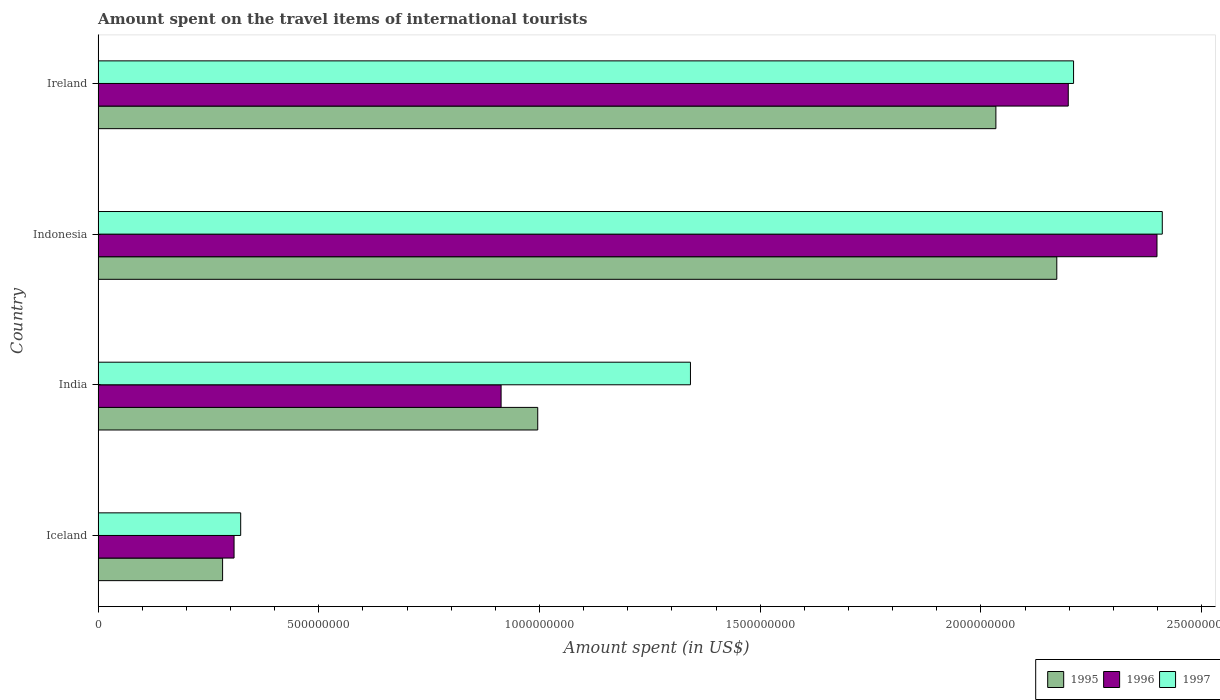How many groups of bars are there?
Offer a terse response. 4. Are the number of bars per tick equal to the number of legend labels?
Make the answer very short. Yes. Are the number of bars on each tick of the Y-axis equal?
Keep it short and to the point. Yes. What is the label of the 3rd group of bars from the top?
Your response must be concise. India. What is the amount spent on the travel items of international tourists in 1997 in Iceland?
Provide a succinct answer. 3.23e+08. Across all countries, what is the maximum amount spent on the travel items of international tourists in 1997?
Keep it short and to the point. 2.41e+09. Across all countries, what is the minimum amount spent on the travel items of international tourists in 1996?
Ensure brevity in your answer.  3.08e+08. In which country was the amount spent on the travel items of international tourists in 1996 maximum?
Make the answer very short. Indonesia. In which country was the amount spent on the travel items of international tourists in 1997 minimum?
Make the answer very short. Iceland. What is the total amount spent on the travel items of international tourists in 1995 in the graph?
Give a very brief answer. 5.48e+09. What is the difference between the amount spent on the travel items of international tourists in 1995 in Iceland and that in Indonesia?
Keep it short and to the point. -1.89e+09. What is the difference between the amount spent on the travel items of international tourists in 1997 in India and the amount spent on the travel items of international tourists in 1995 in Indonesia?
Keep it short and to the point. -8.30e+08. What is the average amount spent on the travel items of international tourists in 1996 per country?
Make the answer very short. 1.45e+09. What is the difference between the amount spent on the travel items of international tourists in 1995 and amount spent on the travel items of international tourists in 1997 in India?
Your response must be concise. -3.46e+08. In how many countries, is the amount spent on the travel items of international tourists in 1995 greater than 400000000 US$?
Your answer should be compact. 3. What is the ratio of the amount spent on the travel items of international tourists in 1996 in India to that in Indonesia?
Provide a short and direct response. 0.38. Is the amount spent on the travel items of international tourists in 1996 in Indonesia less than that in Ireland?
Offer a terse response. No. What is the difference between the highest and the second highest amount spent on the travel items of international tourists in 1995?
Give a very brief answer. 1.38e+08. What is the difference between the highest and the lowest amount spent on the travel items of international tourists in 1997?
Your answer should be compact. 2.09e+09. In how many countries, is the amount spent on the travel items of international tourists in 1996 greater than the average amount spent on the travel items of international tourists in 1996 taken over all countries?
Ensure brevity in your answer.  2. Is the sum of the amount spent on the travel items of international tourists in 1997 in Indonesia and Ireland greater than the maximum amount spent on the travel items of international tourists in 1995 across all countries?
Your response must be concise. Yes. Is it the case that in every country, the sum of the amount spent on the travel items of international tourists in 1995 and amount spent on the travel items of international tourists in 1997 is greater than the amount spent on the travel items of international tourists in 1996?
Keep it short and to the point. Yes. Does the graph contain any zero values?
Keep it short and to the point. No. How many legend labels are there?
Give a very brief answer. 3. What is the title of the graph?
Your answer should be very brief. Amount spent on the travel items of international tourists. Does "1993" appear as one of the legend labels in the graph?
Your answer should be compact. No. What is the label or title of the X-axis?
Your response must be concise. Amount spent (in US$). What is the Amount spent (in US$) of 1995 in Iceland?
Your answer should be very brief. 2.82e+08. What is the Amount spent (in US$) of 1996 in Iceland?
Provide a succinct answer. 3.08e+08. What is the Amount spent (in US$) in 1997 in Iceland?
Make the answer very short. 3.23e+08. What is the Amount spent (in US$) of 1995 in India?
Keep it short and to the point. 9.96e+08. What is the Amount spent (in US$) in 1996 in India?
Your answer should be compact. 9.13e+08. What is the Amount spent (in US$) in 1997 in India?
Offer a terse response. 1.34e+09. What is the Amount spent (in US$) in 1995 in Indonesia?
Keep it short and to the point. 2.17e+09. What is the Amount spent (in US$) in 1996 in Indonesia?
Offer a terse response. 2.40e+09. What is the Amount spent (in US$) of 1997 in Indonesia?
Offer a very short reply. 2.41e+09. What is the Amount spent (in US$) in 1995 in Ireland?
Your answer should be very brief. 2.03e+09. What is the Amount spent (in US$) in 1996 in Ireland?
Your answer should be compact. 2.20e+09. What is the Amount spent (in US$) in 1997 in Ireland?
Provide a short and direct response. 2.21e+09. Across all countries, what is the maximum Amount spent (in US$) of 1995?
Offer a very short reply. 2.17e+09. Across all countries, what is the maximum Amount spent (in US$) in 1996?
Your answer should be very brief. 2.40e+09. Across all countries, what is the maximum Amount spent (in US$) in 1997?
Make the answer very short. 2.41e+09. Across all countries, what is the minimum Amount spent (in US$) in 1995?
Ensure brevity in your answer.  2.82e+08. Across all countries, what is the minimum Amount spent (in US$) in 1996?
Offer a terse response. 3.08e+08. Across all countries, what is the minimum Amount spent (in US$) of 1997?
Offer a very short reply. 3.23e+08. What is the total Amount spent (in US$) in 1995 in the graph?
Offer a very short reply. 5.48e+09. What is the total Amount spent (in US$) of 1996 in the graph?
Ensure brevity in your answer.  5.82e+09. What is the total Amount spent (in US$) in 1997 in the graph?
Your answer should be very brief. 6.29e+09. What is the difference between the Amount spent (in US$) of 1995 in Iceland and that in India?
Provide a short and direct response. -7.14e+08. What is the difference between the Amount spent (in US$) in 1996 in Iceland and that in India?
Your answer should be compact. -6.05e+08. What is the difference between the Amount spent (in US$) of 1997 in Iceland and that in India?
Give a very brief answer. -1.02e+09. What is the difference between the Amount spent (in US$) in 1995 in Iceland and that in Indonesia?
Give a very brief answer. -1.89e+09. What is the difference between the Amount spent (in US$) of 1996 in Iceland and that in Indonesia?
Your answer should be compact. -2.09e+09. What is the difference between the Amount spent (in US$) in 1997 in Iceland and that in Indonesia?
Give a very brief answer. -2.09e+09. What is the difference between the Amount spent (in US$) of 1995 in Iceland and that in Ireland?
Offer a very short reply. -1.75e+09. What is the difference between the Amount spent (in US$) of 1996 in Iceland and that in Ireland?
Provide a short and direct response. -1.89e+09. What is the difference between the Amount spent (in US$) of 1997 in Iceland and that in Ireland?
Offer a very short reply. -1.89e+09. What is the difference between the Amount spent (in US$) in 1995 in India and that in Indonesia?
Ensure brevity in your answer.  -1.18e+09. What is the difference between the Amount spent (in US$) in 1996 in India and that in Indonesia?
Make the answer very short. -1.49e+09. What is the difference between the Amount spent (in US$) of 1997 in India and that in Indonesia?
Provide a short and direct response. -1.07e+09. What is the difference between the Amount spent (in US$) in 1995 in India and that in Ireland?
Offer a very short reply. -1.04e+09. What is the difference between the Amount spent (in US$) in 1996 in India and that in Ireland?
Offer a terse response. -1.28e+09. What is the difference between the Amount spent (in US$) of 1997 in India and that in Ireland?
Give a very brief answer. -8.68e+08. What is the difference between the Amount spent (in US$) in 1995 in Indonesia and that in Ireland?
Ensure brevity in your answer.  1.38e+08. What is the difference between the Amount spent (in US$) of 1996 in Indonesia and that in Ireland?
Provide a short and direct response. 2.01e+08. What is the difference between the Amount spent (in US$) in 1997 in Indonesia and that in Ireland?
Ensure brevity in your answer.  2.01e+08. What is the difference between the Amount spent (in US$) in 1995 in Iceland and the Amount spent (in US$) in 1996 in India?
Offer a very short reply. -6.31e+08. What is the difference between the Amount spent (in US$) of 1995 in Iceland and the Amount spent (in US$) of 1997 in India?
Your answer should be very brief. -1.06e+09. What is the difference between the Amount spent (in US$) in 1996 in Iceland and the Amount spent (in US$) in 1997 in India?
Offer a very short reply. -1.03e+09. What is the difference between the Amount spent (in US$) of 1995 in Iceland and the Amount spent (in US$) of 1996 in Indonesia?
Your response must be concise. -2.12e+09. What is the difference between the Amount spent (in US$) in 1995 in Iceland and the Amount spent (in US$) in 1997 in Indonesia?
Your answer should be very brief. -2.13e+09. What is the difference between the Amount spent (in US$) in 1996 in Iceland and the Amount spent (in US$) in 1997 in Indonesia?
Your answer should be compact. -2.10e+09. What is the difference between the Amount spent (in US$) of 1995 in Iceland and the Amount spent (in US$) of 1996 in Ireland?
Offer a very short reply. -1.92e+09. What is the difference between the Amount spent (in US$) of 1995 in Iceland and the Amount spent (in US$) of 1997 in Ireland?
Provide a short and direct response. -1.93e+09. What is the difference between the Amount spent (in US$) of 1996 in Iceland and the Amount spent (in US$) of 1997 in Ireland?
Give a very brief answer. -1.90e+09. What is the difference between the Amount spent (in US$) in 1995 in India and the Amount spent (in US$) in 1996 in Indonesia?
Your response must be concise. -1.40e+09. What is the difference between the Amount spent (in US$) in 1995 in India and the Amount spent (in US$) in 1997 in Indonesia?
Your answer should be very brief. -1.42e+09. What is the difference between the Amount spent (in US$) of 1996 in India and the Amount spent (in US$) of 1997 in Indonesia?
Ensure brevity in your answer.  -1.50e+09. What is the difference between the Amount spent (in US$) in 1995 in India and the Amount spent (in US$) in 1996 in Ireland?
Offer a terse response. -1.20e+09. What is the difference between the Amount spent (in US$) of 1995 in India and the Amount spent (in US$) of 1997 in Ireland?
Ensure brevity in your answer.  -1.21e+09. What is the difference between the Amount spent (in US$) of 1996 in India and the Amount spent (in US$) of 1997 in Ireland?
Provide a short and direct response. -1.30e+09. What is the difference between the Amount spent (in US$) of 1995 in Indonesia and the Amount spent (in US$) of 1996 in Ireland?
Your answer should be very brief. -2.60e+07. What is the difference between the Amount spent (in US$) in 1995 in Indonesia and the Amount spent (in US$) in 1997 in Ireland?
Give a very brief answer. -3.80e+07. What is the difference between the Amount spent (in US$) of 1996 in Indonesia and the Amount spent (in US$) of 1997 in Ireland?
Offer a very short reply. 1.89e+08. What is the average Amount spent (in US$) of 1995 per country?
Your response must be concise. 1.37e+09. What is the average Amount spent (in US$) in 1996 per country?
Offer a terse response. 1.45e+09. What is the average Amount spent (in US$) in 1997 per country?
Keep it short and to the point. 1.57e+09. What is the difference between the Amount spent (in US$) in 1995 and Amount spent (in US$) in 1996 in Iceland?
Ensure brevity in your answer.  -2.60e+07. What is the difference between the Amount spent (in US$) in 1995 and Amount spent (in US$) in 1997 in Iceland?
Make the answer very short. -4.10e+07. What is the difference between the Amount spent (in US$) of 1996 and Amount spent (in US$) of 1997 in Iceland?
Your response must be concise. -1.50e+07. What is the difference between the Amount spent (in US$) in 1995 and Amount spent (in US$) in 1996 in India?
Offer a terse response. 8.30e+07. What is the difference between the Amount spent (in US$) in 1995 and Amount spent (in US$) in 1997 in India?
Provide a short and direct response. -3.46e+08. What is the difference between the Amount spent (in US$) in 1996 and Amount spent (in US$) in 1997 in India?
Keep it short and to the point. -4.29e+08. What is the difference between the Amount spent (in US$) of 1995 and Amount spent (in US$) of 1996 in Indonesia?
Ensure brevity in your answer.  -2.27e+08. What is the difference between the Amount spent (in US$) in 1995 and Amount spent (in US$) in 1997 in Indonesia?
Keep it short and to the point. -2.39e+08. What is the difference between the Amount spent (in US$) in 1996 and Amount spent (in US$) in 1997 in Indonesia?
Ensure brevity in your answer.  -1.20e+07. What is the difference between the Amount spent (in US$) of 1995 and Amount spent (in US$) of 1996 in Ireland?
Offer a terse response. -1.64e+08. What is the difference between the Amount spent (in US$) in 1995 and Amount spent (in US$) in 1997 in Ireland?
Provide a succinct answer. -1.76e+08. What is the difference between the Amount spent (in US$) in 1996 and Amount spent (in US$) in 1997 in Ireland?
Provide a succinct answer. -1.20e+07. What is the ratio of the Amount spent (in US$) in 1995 in Iceland to that in India?
Offer a terse response. 0.28. What is the ratio of the Amount spent (in US$) of 1996 in Iceland to that in India?
Your answer should be very brief. 0.34. What is the ratio of the Amount spent (in US$) of 1997 in Iceland to that in India?
Your answer should be compact. 0.24. What is the ratio of the Amount spent (in US$) of 1995 in Iceland to that in Indonesia?
Offer a very short reply. 0.13. What is the ratio of the Amount spent (in US$) of 1996 in Iceland to that in Indonesia?
Make the answer very short. 0.13. What is the ratio of the Amount spent (in US$) in 1997 in Iceland to that in Indonesia?
Your answer should be very brief. 0.13. What is the ratio of the Amount spent (in US$) of 1995 in Iceland to that in Ireland?
Offer a terse response. 0.14. What is the ratio of the Amount spent (in US$) of 1996 in Iceland to that in Ireland?
Make the answer very short. 0.14. What is the ratio of the Amount spent (in US$) of 1997 in Iceland to that in Ireland?
Keep it short and to the point. 0.15. What is the ratio of the Amount spent (in US$) in 1995 in India to that in Indonesia?
Offer a terse response. 0.46. What is the ratio of the Amount spent (in US$) in 1996 in India to that in Indonesia?
Offer a terse response. 0.38. What is the ratio of the Amount spent (in US$) of 1997 in India to that in Indonesia?
Give a very brief answer. 0.56. What is the ratio of the Amount spent (in US$) in 1995 in India to that in Ireland?
Make the answer very short. 0.49. What is the ratio of the Amount spent (in US$) of 1996 in India to that in Ireland?
Provide a short and direct response. 0.42. What is the ratio of the Amount spent (in US$) of 1997 in India to that in Ireland?
Your response must be concise. 0.61. What is the ratio of the Amount spent (in US$) of 1995 in Indonesia to that in Ireland?
Your answer should be compact. 1.07. What is the ratio of the Amount spent (in US$) of 1996 in Indonesia to that in Ireland?
Keep it short and to the point. 1.09. What is the ratio of the Amount spent (in US$) in 1997 in Indonesia to that in Ireland?
Provide a succinct answer. 1.09. What is the difference between the highest and the second highest Amount spent (in US$) in 1995?
Keep it short and to the point. 1.38e+08. What is the difference between the highest and the second highest Amount spent (in US$) of 1996?
Provide a short and direct response. 2.01e+08. What is the difference between the highest and the second highest Amount spent (in US$) in 1997?
Your response must be concise. 2.01e+08. What is the difference between the highest and the lowest Amount spent (in US$) in 1995?
Give a very brief answer. 1.89e+09. What is the difference between the highest and the lowest Amount spent (in US$) in 1996?
Your answer should be very brief. 2.09e+09. What is the difference between the highest and the lowest Amount spent (in US$) in 1997?
Your response must be concise. 2.09e+09. 